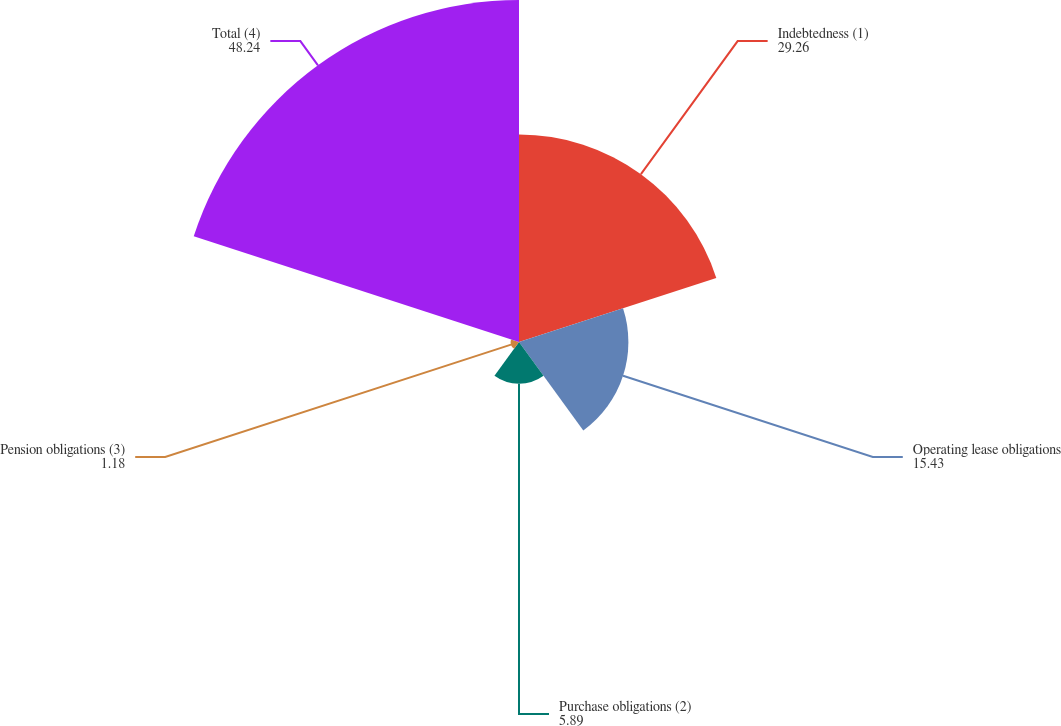Convert chart. <chart><loc_0><loc_0><loc_500><loc_500><pie_chart><fcel>Indebtedness (1)<fcel>Operating lease obligations<fcel>Purchase obligations (2)<fcel>Pension obligations (3)<fcel>Total (4)<nl><fcel>29.26%<fcel>15.43%<fcel>5.89%<fcel>1.18%<fcel>48.24%<nl></chart> 